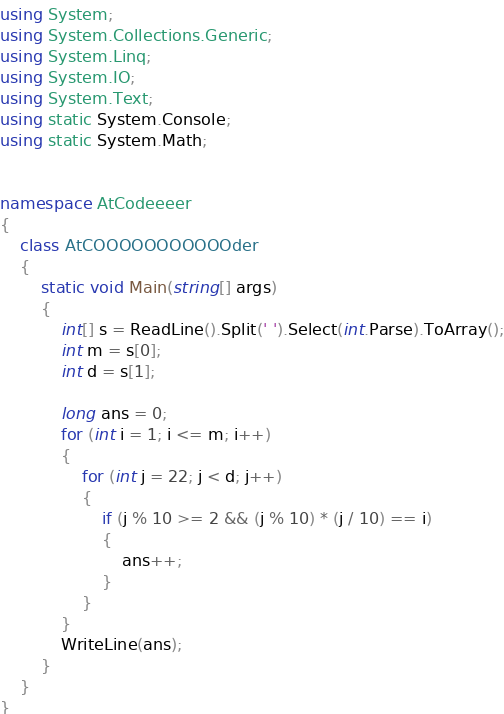<code> <loc_0><loc_0><loc_500><loc_500><_C#_>using System;
using System.Collections.Generic;
using System.Linq;
using System.IO;
using System.Text;
using static System.Console;
using static System.Math;


namespace AtCodeeeer
{
    class AtCOOOOOOOOOOOder
    {
        static void Main(string[] args)
        {
            int[] s = ReadLine().Split(' ').Select(int.Parse).ToArray();
            int m = s[0];
            int d = s[1];

            long ans = 0;
            for (int i = 1; i <= m; i++)
            {
                for (int j = 22; j < d; j++)
                {
                    if (j % 10 >= 2 && (j % 10) * (j / 10) == i)
                    {
                        ans++;
                    }
                }
            }
            WriteLine(ans);
        }
    }
}
</code> 